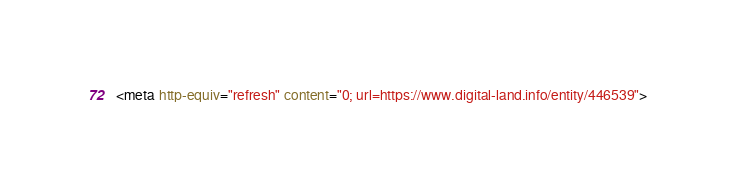<code> <loc_0><loc_0><loc_500><loc_500><_HTML_><meta http-equiv="refresh" content="0; url=https://www.digital-land.info/entity/446539"></code> 